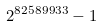Convert formula to latex. <formula><loc_0><loc_0><loc_500><loc_500>2 ^ { 8 2 5 8 9 9 3 3 } - 1</formula> 